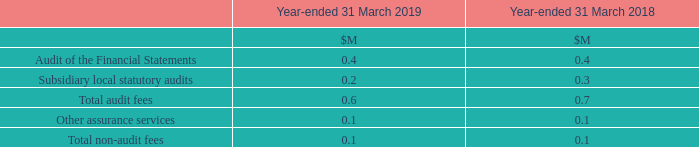10 Auditor’s Remuneration
The Group paid the following amounts to its auditor in respect of the audit of the historical financial information and for other non-audit services provided to the Group.
What did the Group pay the following amounts to its auditor in respect to? In respect of the audit of the historical financial information and for other non-audit services provided to the group. What is the Audit of the Financial Statements fees for 2019?
Answer scale should be: million. 0.4. What are the items under Total audit fees in the table? Audit of the financial statements, subsidiary local statutory audits. In which year was the amount of Total audit fees larger? 0.7>0.6
Answer: 2018. What was the change in Total audit fees in 2019 from 2018?
Answer scale should be: million. 0.6-0.7
Answer: -0.1. What was the percentage change in Total audit fees in 2019 from 2018?
Answer scale should be: percent. (0.6-0.7)/0.7
Answer: -14.29. 